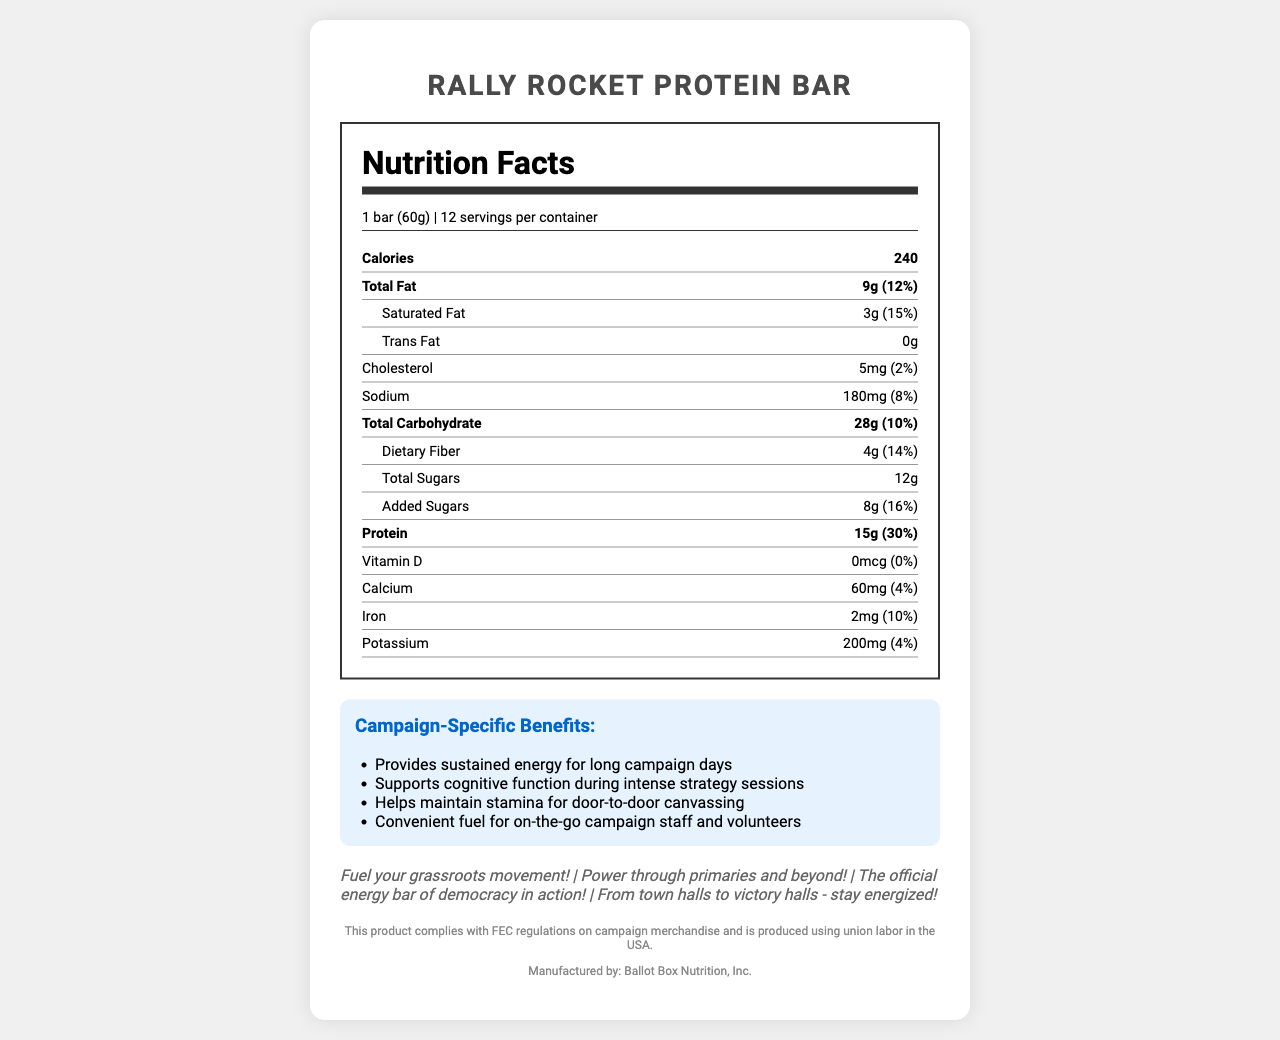who is the manufacturer of the Rally Rocket Protein Bar? The manufacturer information is explicitly mentioned in the document under the compliance section.
Answer: Ballot Box Nutrition, Inc. how many calories are in one serving of the Rally Rocket Protein Bar? The calorie content is listed as 240 on the Nutrition Facts label.
Answer: 240 how much protein is in each serving of the Rally Rocket Protein Bar? The amount of protein is listed as 15g on the Nutrition Facts label.
Answer: 15g what is the serving size of the Rally Rocket Protein Bar? The serving size is specified as "1 bar (60g)" in the document.
Answer: 1 bar (60g) what ingredients are in the Rally Rocket Protein Bar? The ingredients are listed towards the end of the document.
Answer: Protein blend (whey protein isolate, soy protein isolate), brown rice syrup, almonds, dried cranberries, oats, glycerin, sunflower oil, natural flavors, sea salt, soy lecithin how many servings per container are there? The number of servings per container is listed as 12.
Answer: 12 what allergens are contained in the Rally Rocket Protein Bar? The allergen information is explicitly mentioned in the document.
Answer: Contains milk, soy, and tree nuts (almonds). May contain traces of peanuts and other tree nuts. how much dietary fiber does the bar provide? The amount of dietary fiber is listed as 4g on the Nutrition Facts label.
Answer: 4g how many grams of added sugars are there in the protein bar? The amount of added sugars is listed as 8g on the Nutrition Facts label.
Answer: 8g Which of the following nutrients is not present in the Rally Rocket Protein Bar? 1. Trans Fat 2. Vitamin D 3. Iron 4. Calcium Vitamin D is listed with an amount of 0mcg and a daily value of 0%.
Answer: 2. Vitamin D What is the marketing slogan mentioned in the document? A. Power through primaries and beyond B. Provides sustained energy for long campaign days C. Helps maintain stamina for door-to-door canvassing "Power through primaries and beyond" is one of the marketing slogans specifically mentioned in the document.
Answer: A. Power through primaries and beyond How much calcium is present in each serving of the Rally Rocket Protein Bar? 1. 30mg 2. 60mg 3. 40mg 4. 90mg The amount of calcium per serving is 60mg as mentioned in the Nutrition Facts.
Answer: 2. 60mg is the protein bar compliant with FEC regulations? The compliance statement in the document explicitly mentions that the product complies with FEC regulations.
Answer: Yes what benefits are claimed for the "Rally Rocket Protein Bar" targeted at political campaigns? These benefits are explicitly listed under "Campaign-Specific Benefits" in the document.
Answer: The benefits claimed include providing sustained energy for long campaign days, supporting cognitive function during intense strategy sessions, helping maintain stamina for door-to-door canvassing, and being a convenient fuel for on-the-go campaign staff and volunteers. what is the main idea of the document? The document integrates nutritional facts, campaign-specific benefits, and compliance statements, positioning the product as an ideal energy source for political campaign activities.
Answer: The document provides detailed nutritional information about the Rally Rocket Protein Bar, highlighting its ingredients, caloric content, and nutritional values. It also markets the bar specifically for political campaigns, emphasizing sustained energy and other benefits for campaign staff and volunteers, along with compliance information and marketing slogans. where is the protein blend sourced from? The document does not provide any information on the source of the protein blend.
Answer: Cannot be determined 